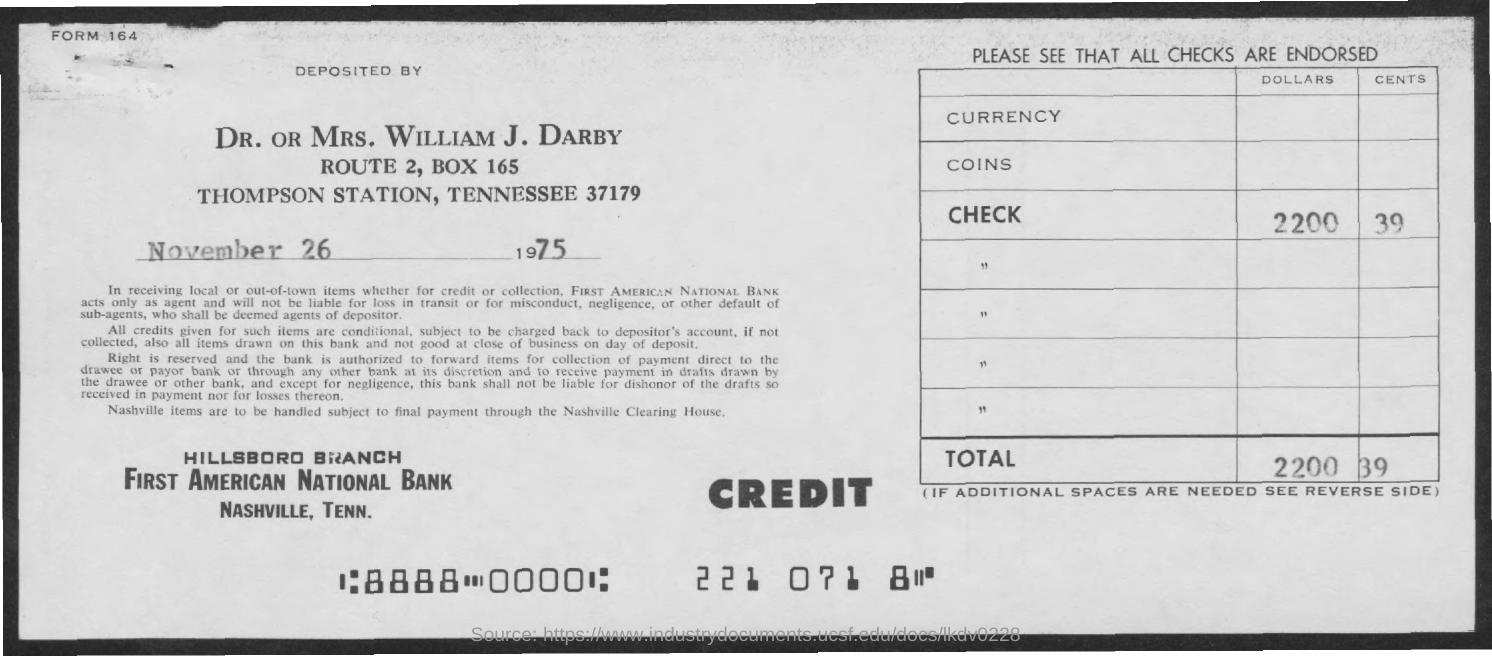What is the date on the document?
Keep it short and to the point. NOVEMBER 26 1975. What is the Check amount?
Provide a succinct answer. 2200.39. What is the Total?
Make the answer very short. 2200.39. 